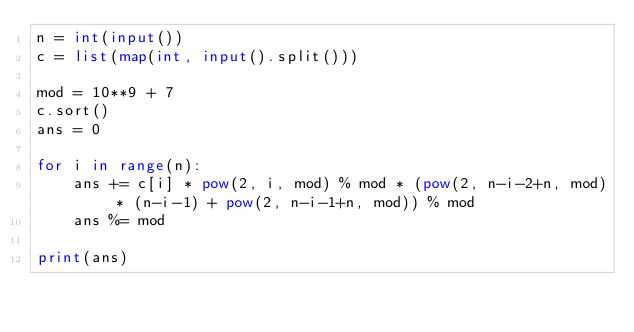<code> <loc_0><loc_0><loc_500><loc_500><_Python_>n = int(input())
c = list(map(int, input().split()))

mod = 10**9 + 7
c.sort()
ans = 0

for i in range(n):
    ans += c[i] * pow(2, i, mod) % mod * (pow(2, n-i-2+n, mod) * (n-i-1) + pow(2, n-i-1+n, mod)) % mod
    ans %= mod

print(ans)
</code> 